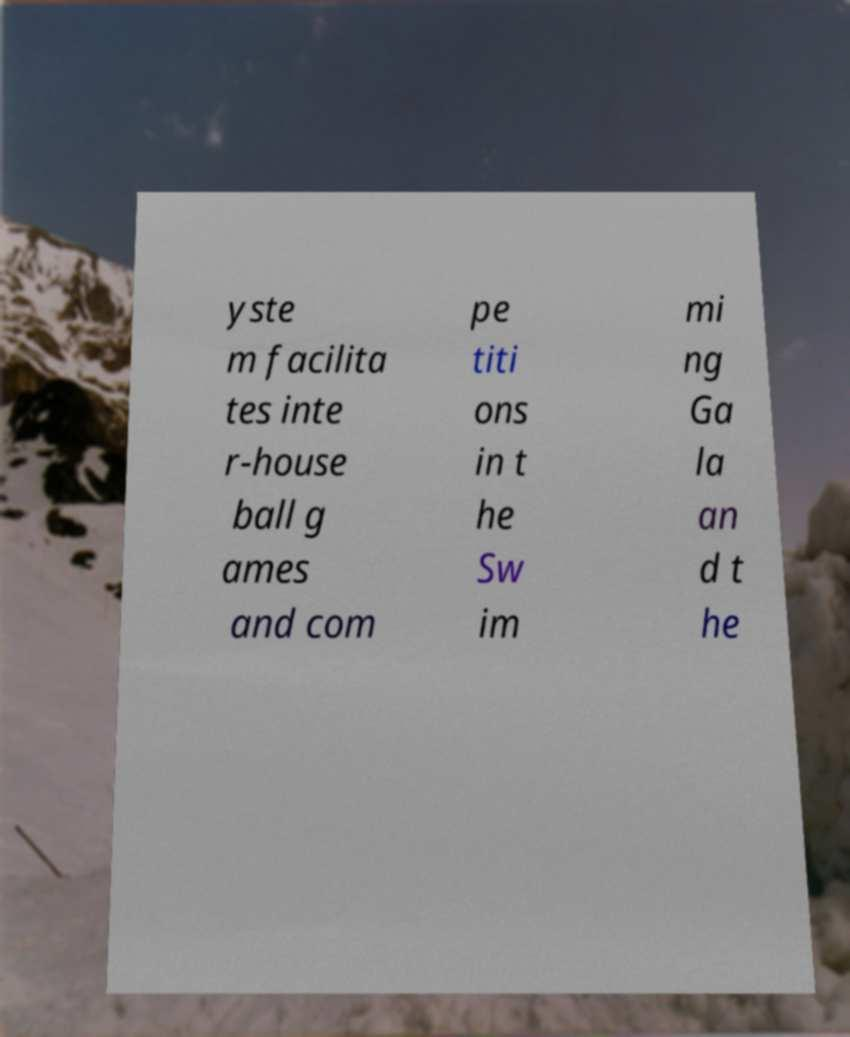Can you accurately transcribe the text from the provided image for me? yste m facilita tes inte r-house ball g ames and com pe titi ons in t he Sw im mi ng Ga la an d t he 